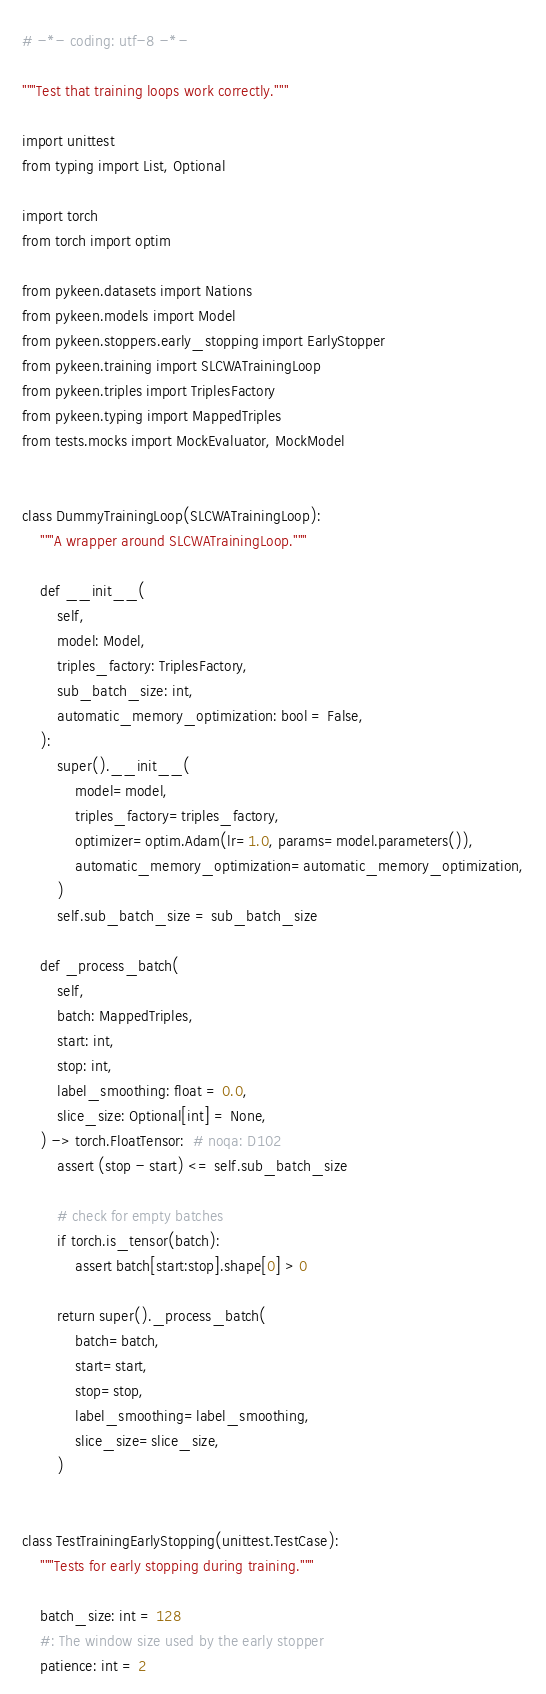<code> <loc_0><loc_0><loc_500><loc_500><_Python_># -*- coding: utf-8 -*-

"""Test that training loops work correctly."""

import unittest
from typing import List, Optional

import torch
from torch import optim

from pykeen.datasets import Nations
from pykeen.models import Model
from pykeen.stoppers.early_stopping import EarlyStopper
from pykeen.training import SLCWATrainingLoop
from pykeen.triples import TriplesFactory
from pykeen.typing import MappedTriples
from tests.mocks import MockEvaluator, MockModel


class DummyTrainingLoop(SLCWATrainingLoop):
    """A wrapper around SLCWATrainingLoop."""

    def __init__(
        self,
        model: Model,
        triples_factory: TriplesFactory,
        sub_batch_size: int,
        automatic_memory_optimization: bool = False,
    ):
        super().__init__(
            model=model,
            triples_factory=triples_factory,
            optimizer=optim.Adam(lr=1.0, params=model.parameters()),
            automatic_memory_optimization=automatic_memory_optimization,
        )
        self.sub_batch_size = sub_batch_size

    def _process_batch(
        self,
        batch: MappedTriples,
        start: int,
        stop: int,
        label_smoothing: float = 0.0,
        slice_size: Optional[int] = None,
    ) -> torch.FloatTensor:  # noqa: D102
        assert (stop - start) <= self.sub_batch_size

        # check for empty batches
        if torch.is_tensor(batch):
            assert batch[start:stop].shape[0] > 0

        return super()._process_batch(
            batch=batch,
            start=start,
            stop=stop,
            label_smoothing=label_smoothing,
            slice_size=slice_size,
        )


class TestTrainingEarlyStopping(unittest.TestCase):
    """Tests for early stopping during training."""

    batch_size: int = 128
    #: The window size used by the early stopper
    patience: int = 2</code> 